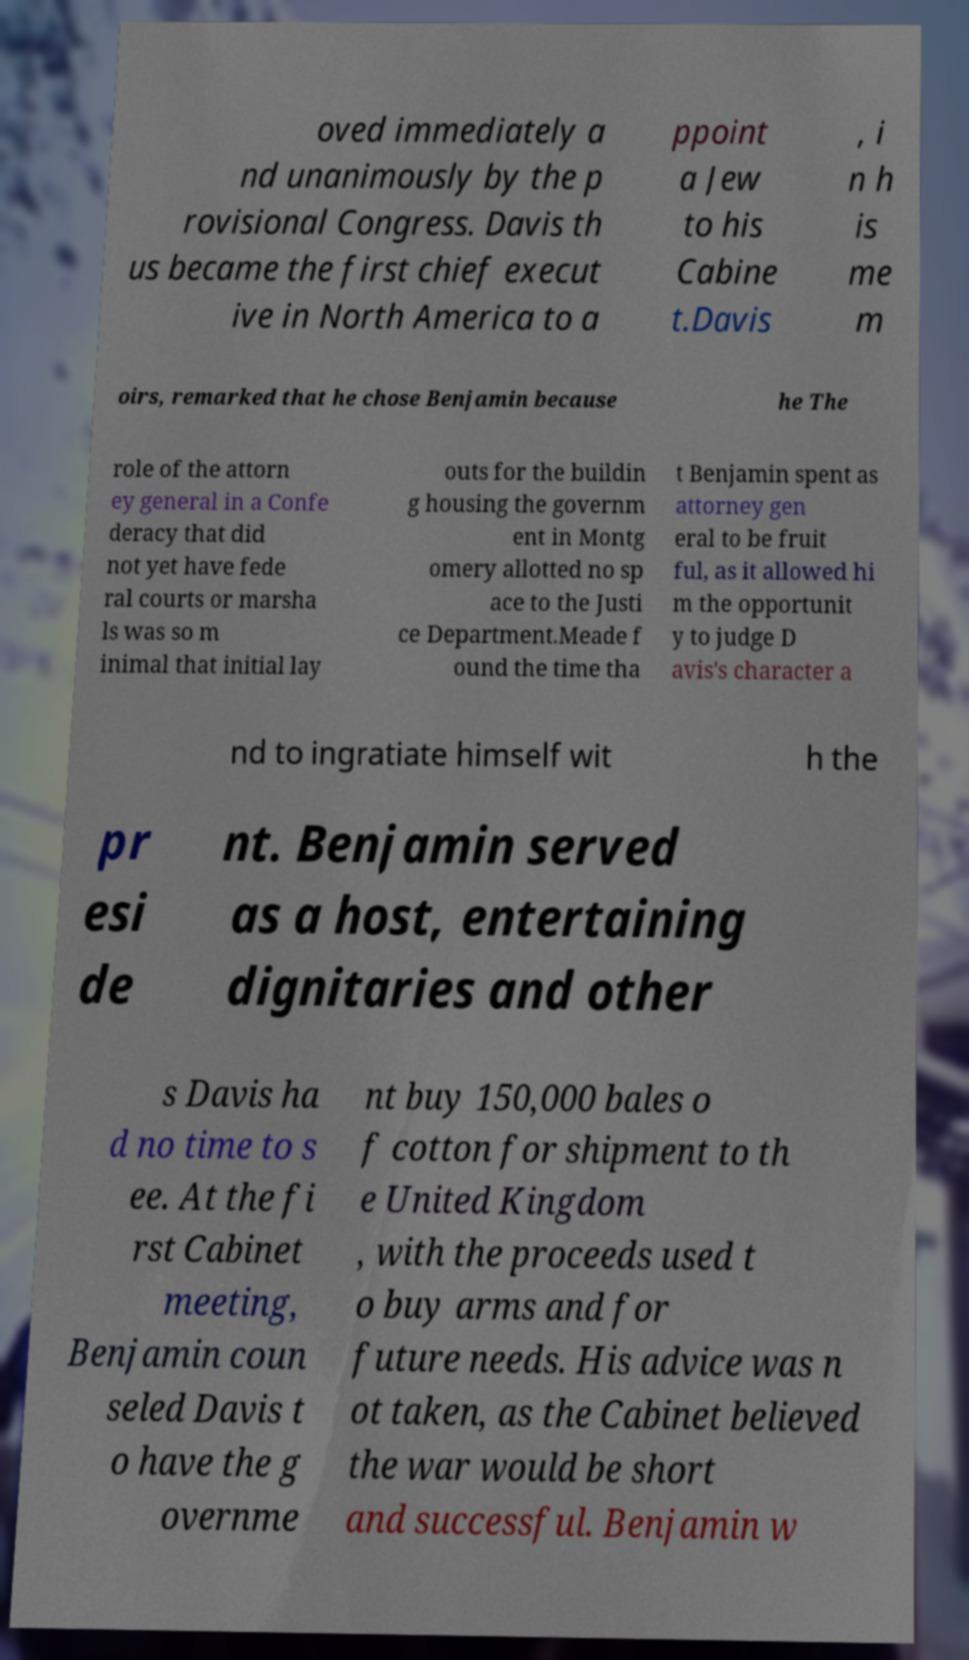Can you read and provide the text displayed in the image?This photo seems to have some interesting text. Can you extract and type it out for me? oved immediately a nd unanimously by the p rovisional Congress. Davis th us became the first chief execut ive in North America to a ppoint a Jew to his Cabine t.Davis , i n h is me m oirs, remarked that he chose Benjamin because he The role of the attorn ey general in a Confe deracy that did not yet have fede ral courts or marsha ls was so m inimal that initial lay outs for the buildin g housing the governm ent in Montg omery allotted no sp ace to the Justi ce Department.Meade f ound the time tha t Benjamin spent as attorney gen eral to be fruit ful, as it allowed hi m the opportunit y to judge D avis's character a nd to ingratiate himself wit h the pr esi de nt. Benjamin served as a host, entertaining dignitaries and other s Davis ha d no time to s ee. At the fi rst Cabinet meeting, Benjamin coun seled Davis t o have the g overnme nt buy 150,000 bales o f cotton for shipment to th e United Kingdom , with the proceeds used t o buy arms and for future needs. His advice was n ot taken, as the Cabinet believed the war would be short and successful. Benjamin w 